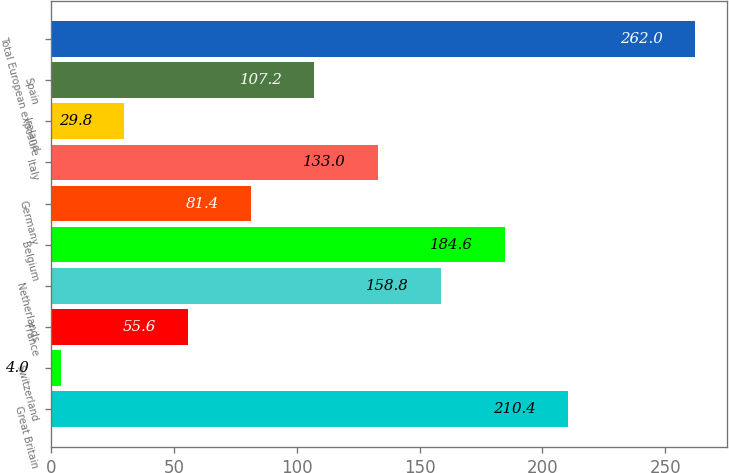Convert chart. <chart><loc_0><loc_0><loc_500><loc_500><bar_chart><fcel>Great Britain<fcel>Switzerland<fcel>France<fcel>Netherlands<fcel>Belgium<fcel>Germany<fcel>Italy<fcel>Ireland<fcel>Spain<fcel>Total European exposure<nl><fcel>210.4<fcel>4<fcel>55.6<fcel>158.8<fcel>184.6<fcel>81.4<fcel>133<fcel>29.8<fcel>107.2<fcel>262<nl></chart> 